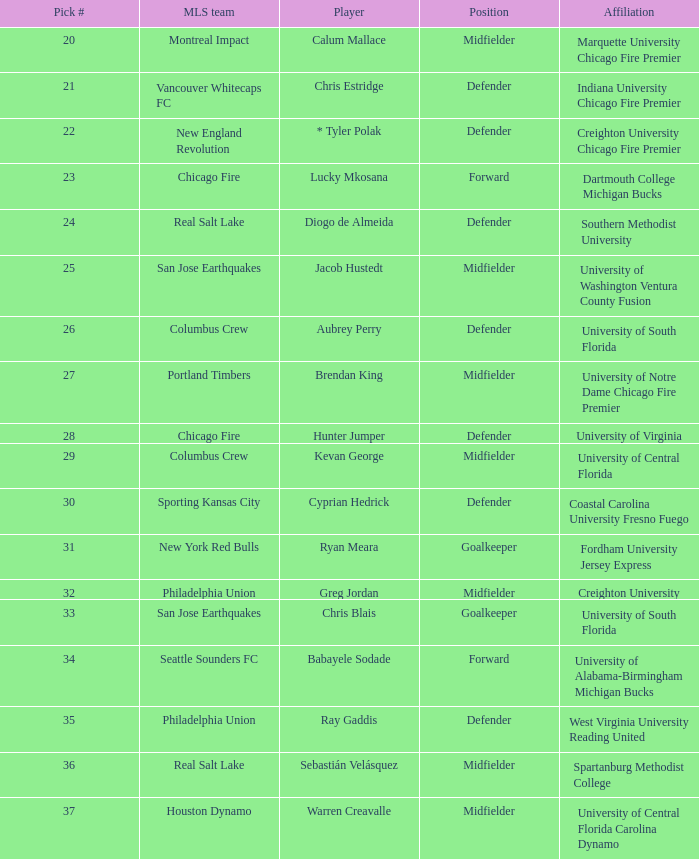What university was Kevan George affiliated with? University of Central Florida. 